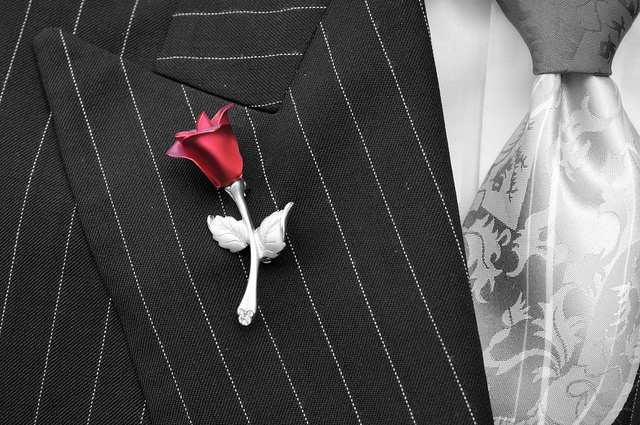Describe the objects in this image and their specific colors. I can see people in black, lightgray, gray, and darkgray tones and tie in black, lightgray, darkgray, and gray tones in this image. 